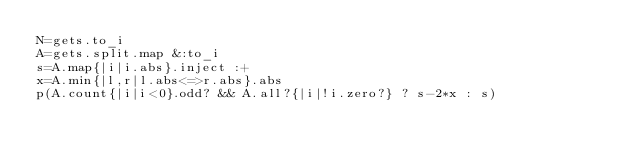Convert code to text. <code><loc_0><loc_0><loc_500><loc_500><_Ruby_>N=gets.to_i
A=gets.split.map &:to_i
s=A.map{|i|i.abs}.inject :+
x=A.min{|l,r|l.abs<=>r.abs}.abs
p(A.count{|i|i<0}.odd? && A.all?{|i|!i.zero?} ? s-2*x : s)</code> 